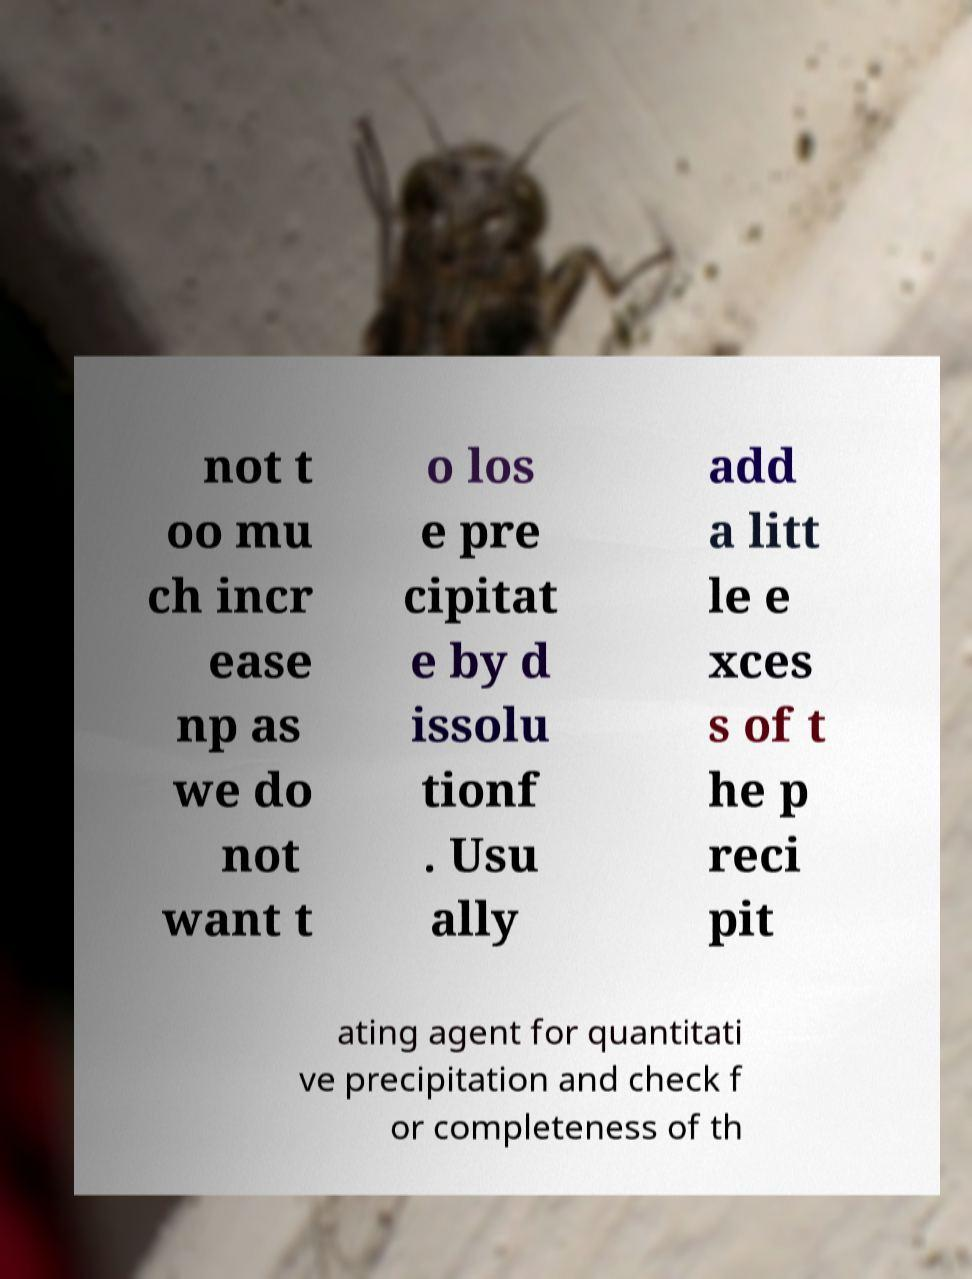Please identify and transcribe the text found in this image. not t oo mu ch incr ease np as we do not want t o los e pre cipitat e by d issolu tionf . Usu ally add a litt le e xces s of t he p reci pit ating agent for quantitati ve precipitation and check f or completeness of th 